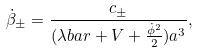<formula> <loc_0><loc_0><loc_500><loc_500>\dot { \beta } _ { \pm } = \frac { c _ { \pm } } { ( \lambda b a r + V + \frac { \dot { \phi } ^ { 2 } } 2 ) a ^ { 3 } } ,</formula> 